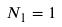<formula> <loc_0><loc_0><loc_500><loc_500>N _ { 1 } = 1</formula> 